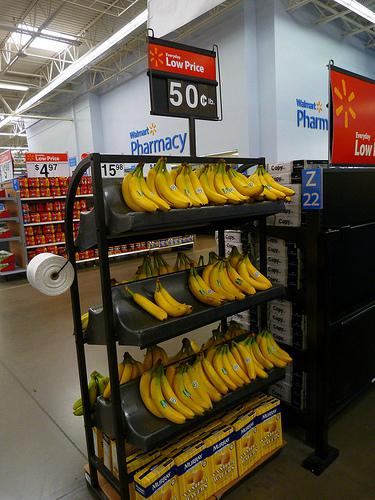Question: why are there stickers on the bananas?
Choices:
A. To show there original location.
B. It shows their brand.
C. To show rather they are organic or not.
D. To show the price.
Answer with the letter. Answer: B Question: what are the yellow things on the rack?
Choices:
A. Lemons.
B. Summer Squash.
C. Bananas.
D. Golden Delicious Apples.
Answer with the letter. Answer: C Question: what color are the bananas?
Choices:
A. Gold.
B. Black.
C. Yellow.
D. Green.
Answer with the letter. Answer: C Question: what store is this?
Choices:
A. Fred Meyer.
B. Target.
C. Aldi.
D. Walmart.
Answer with the letter. Answer: D Question: how many racks holding bananas are visible?
Choices:
A. Two.
B. One.
C. Three.
D. Four.
Answer with the letter. Answer: B 